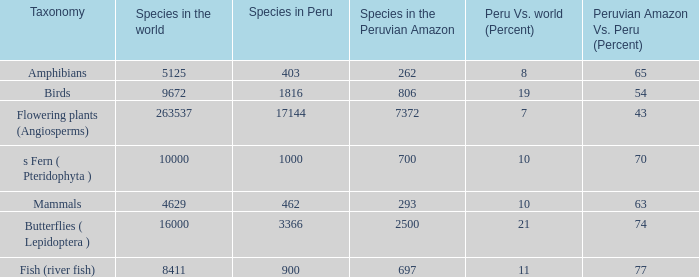What's the minimum species in the peruvian amazon with peru vs. world (percent) value of 7 7372.0. 